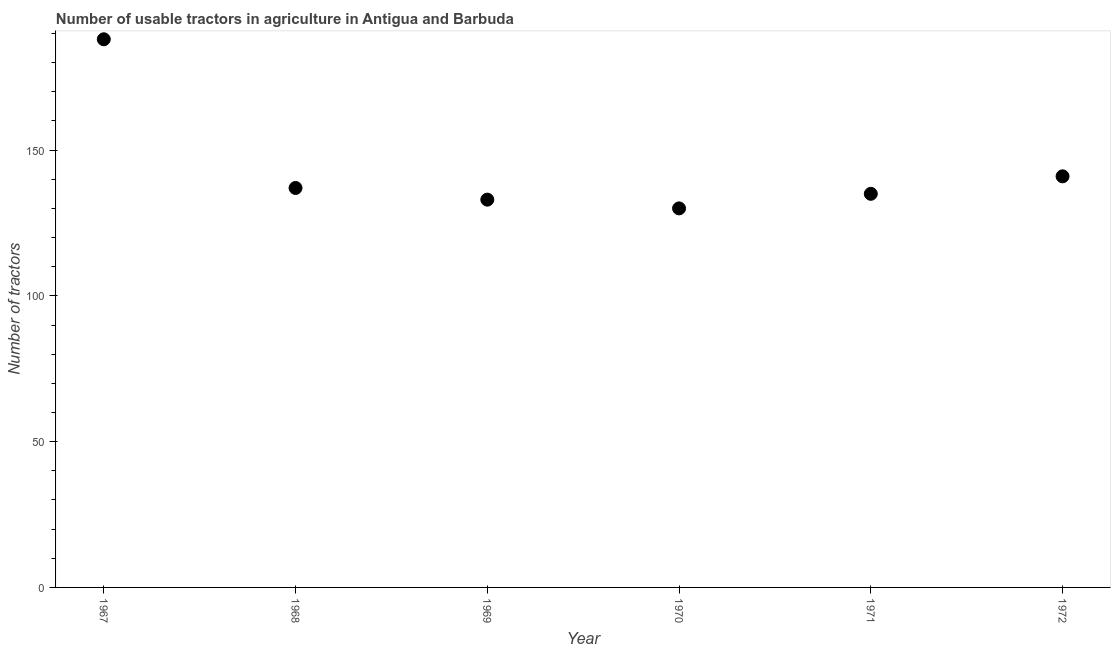What is the number of tractors in 1970?
Ensure brevity in your answer.  130. Across all years, what is the maximum number of tractors?
Your answer should be compact. 188. Across all years, what is the minimum number of tractors?
Keep it short and to the point. 130. In which year was the number of tractors maximum?
Your answer should be very brief. 1967. What is the sum of the number of tractors?
Keep it short and to the point. 864. What is the difference between the number of tractors in 1967 and 1970?
Your answer should be compact. 58. What is the average number of tractors per year?
Make the answer very short. 144. What is the median number of tractors?
Provide a succinct answer. 136. Do a majority of the years between 1968 and 1972 (inclusive) have number of tractors greater than 150 ?
Your answer should be compact. No. What is the ratio of the number of tractors in 1967 to that in 1972?
Provide a succinct answer. 1.33. Is the difference between the number of tractors in 1968 and 1970 greater than the difference between any two years?
Offer a terse response. No. What is the difference between the highest and the lowest number of tractors?
Your response must be concise. 58. How many dotlines are there?
Your response must be concise. 1. How many years are there in the graph?
Offer a very short reply. 6. What is the difference between two consecutive major ticks on the Y-axis?
Your answer should be compact. 50. Does the graph contain any zero values?
Offer a very short reply. No. Does the graph contain grids?
Keep it short and to the point. No. What is the title of the graph?
Keep it short and to the point. Number of usable tractors in agriculture in Antigua and Barbuda. What is the label or title of the X-axis?
Offer a terse response. Year. What is the label or title of the Y-axis?
Offer a very short reply. Number of tractors. What is the Number of tractors in 1967?
Your answer should be very brief. 188. What is the Number of tractors in 1968?
Give a very brief answer. 137. What is the Number of tractors in 1969?
Ensure brevity in your answer.  133. What is the Number of tractors in 1970?
Offer a very short reply. 130. What is the Number of tractors in 1971?
Make the answer very short. 135. What is the Number of tractors in 1972?
Make the answer very short. 141. What is the difference between the Number of tractors in 1967 and 1968?
Your response must be concise. 51. What is the difference between the Number of tractors in 1967 and 1971?
Your answer should be compact. 53. What is the difference between the Number of tractors in 1967 and 1972?
Your answer should be very brief. 47. What is the difference between the Number of tractors in 1968 and 1969?
Offer a very short reply. 4. What is the difference between the Number of tractors in 1968 and 1971?
Your answer should be very brief. 2. What is the difference between the Number of tractors in 1968 and 1972?
Offer a very short reply. -4. What is the difference between the Number of tractors in 1969 and 1970?
Your answer should be compact. 3. What is the difference between the Number of tractors in 1969 and 1971?
Offer a very short reply. -2. What is the difference between the Number of tractors in 1970 and 1971?
Give a very brief answer. -5. What is the difference between the Number of tractors in 1970 and 1972?
Provide a short and direct response. -11. What is the difference between the Number of tractors in 1971 and 1972?
Keep it short and to the point. -6. What is the ratio of the Number of tractors in 1967 to that in 1968?
Provide a short and direct response. 1.37. What is the ratio of the Number of tractors in 1967 to that in 1969?
Give a very brief answer. 1.41. What is the ratio of the Number of tractors in 1967 to that in 1970?
Give a very brief answer. 1.45. What is the ratio of the Number of tractors in 1967 to that in 1971?
Offer a terse response. 1.39. What is the ratio of the Number of tractors in 1967 to that in 1972?
Provide a short and direct response. 1.33. What is the ratio of the Number of tractors in 1968 to that in 1970?
Provide a succinct answer. 1.05. What is the ratio of the Number of tractors in 1968 to that in 1971?
Make the answer very short. 1.01. What is the ratio of the Number of tractors in 1968 to that in 1972?
Make the answer very short. 0.97. What is the ratio of the Number of tractors in 1969 to that in 1970?
Make the answer very short. 1.02. What is the ratio of the Number of tractors in 1969 to that in 1972?
Offer a very short reply. 0.94. What is the ratio of the Number of tractors in 1970 to that in 1971?
Your response must be concise. 0.96. What is the ratio of the Number of tractors in 1970 to that in 1972?
Your answer should be compact. 0.92. 